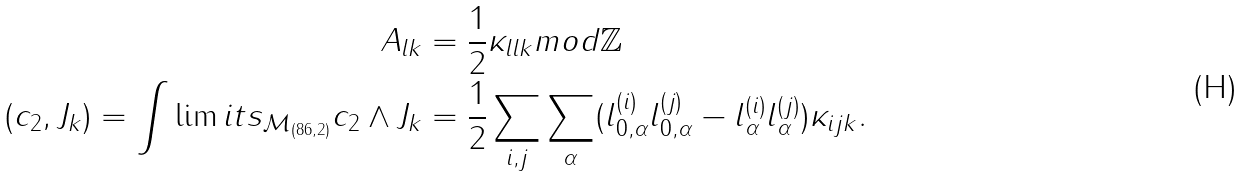<formula> <loc_0><loc_0><loc_500><loc_500>A _ { l k } & = \frac { 1 } { 2 } \kappa _ { l l k } m o d \mathbb { Z } \\ ( c _ { 2 } , J _ { k } ) = \int \lim i t s _ { \mathcal { M } _ { ( 8 6 , 2 ) } } c _ { 2 } \wedge J _ { k } & = \frac { 1 } { 2 } \sum _ { i , j } \sum _ { \alpha } ( l ^ { ( i ) } _ { 0 , \alpha } l ^ { ( j ) } _ { 0 , \alpha } - l ^ { ( i ) } _ { \alpha } l ^ { ( j ) } _ { \alpha } ) \kappa _ { i j k } .</formula> 